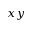<formula> <loc_0><loc_0><loc_500><loc_500>x y</formula> 